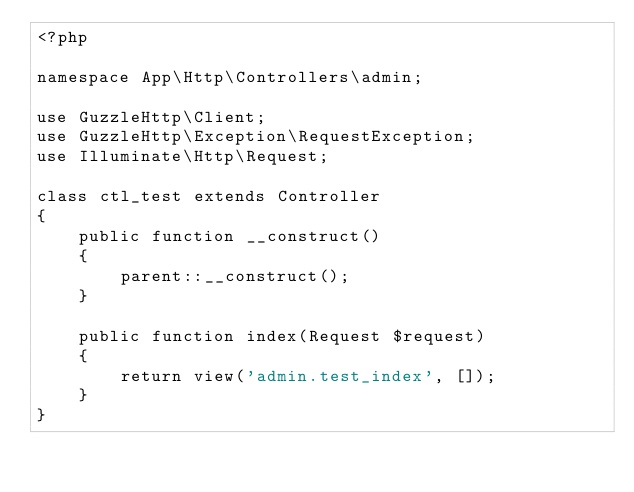<code> <loc_0><loc_0><loc_500><loc_500><_PHP_><?php

namespace App\Http\Controllers\admin;

use GuzzleHttp\Client;
use GuzzleHttp\Exception\RequestException;
use Illuminate\Http\Request;

class ctl_test extends Controller
{
    public function __construct()
    {
        parent::__construct();
    }

    public function index(Request $request)
    {
        return view('admin.test_index', []);
    }
}
</code> 